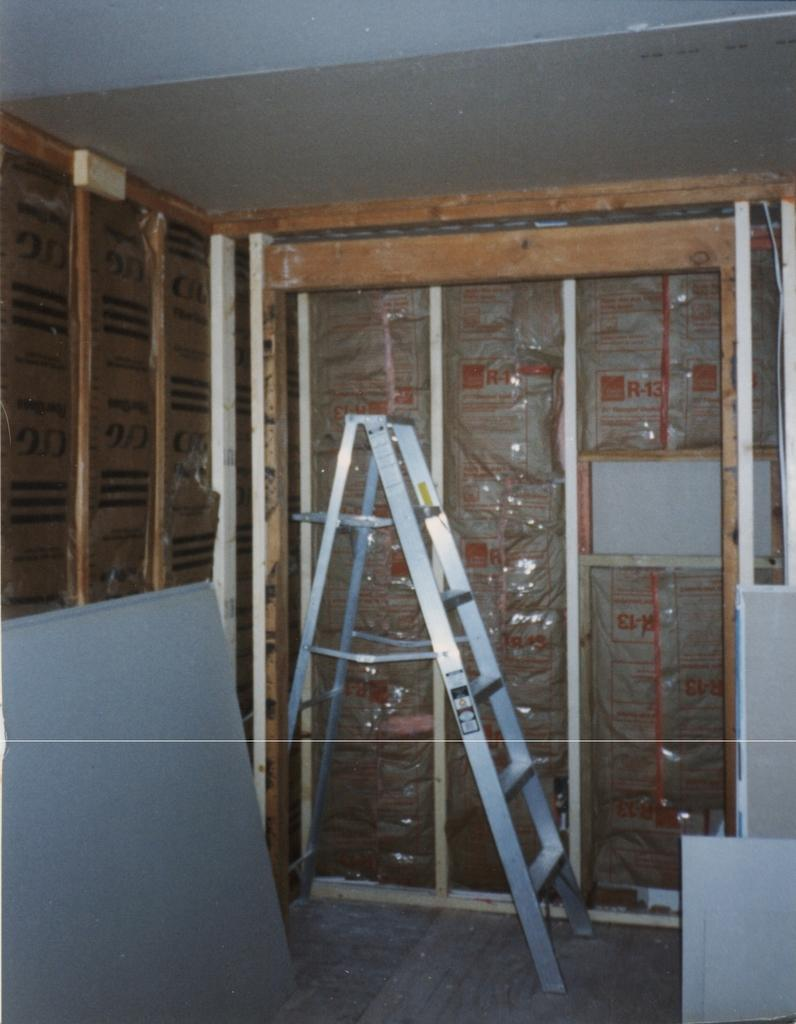What objects are located in the center of the image? There are boards and a ladder in the center of the image. What type of structure might these objects be associated with? The presence of a ladder and boards suggests they could be part of a construction or repair project. What can be seen in the background of the image? There is a roof and glass in the background of the image, along with a few other objects. Can you describe the other objects in the background? Unfortunately, the provided facts do not specify the nature of the other objects in the background. What type of bear can be seen interacting with the stick in the image? There is no bear or stick present in the image. 